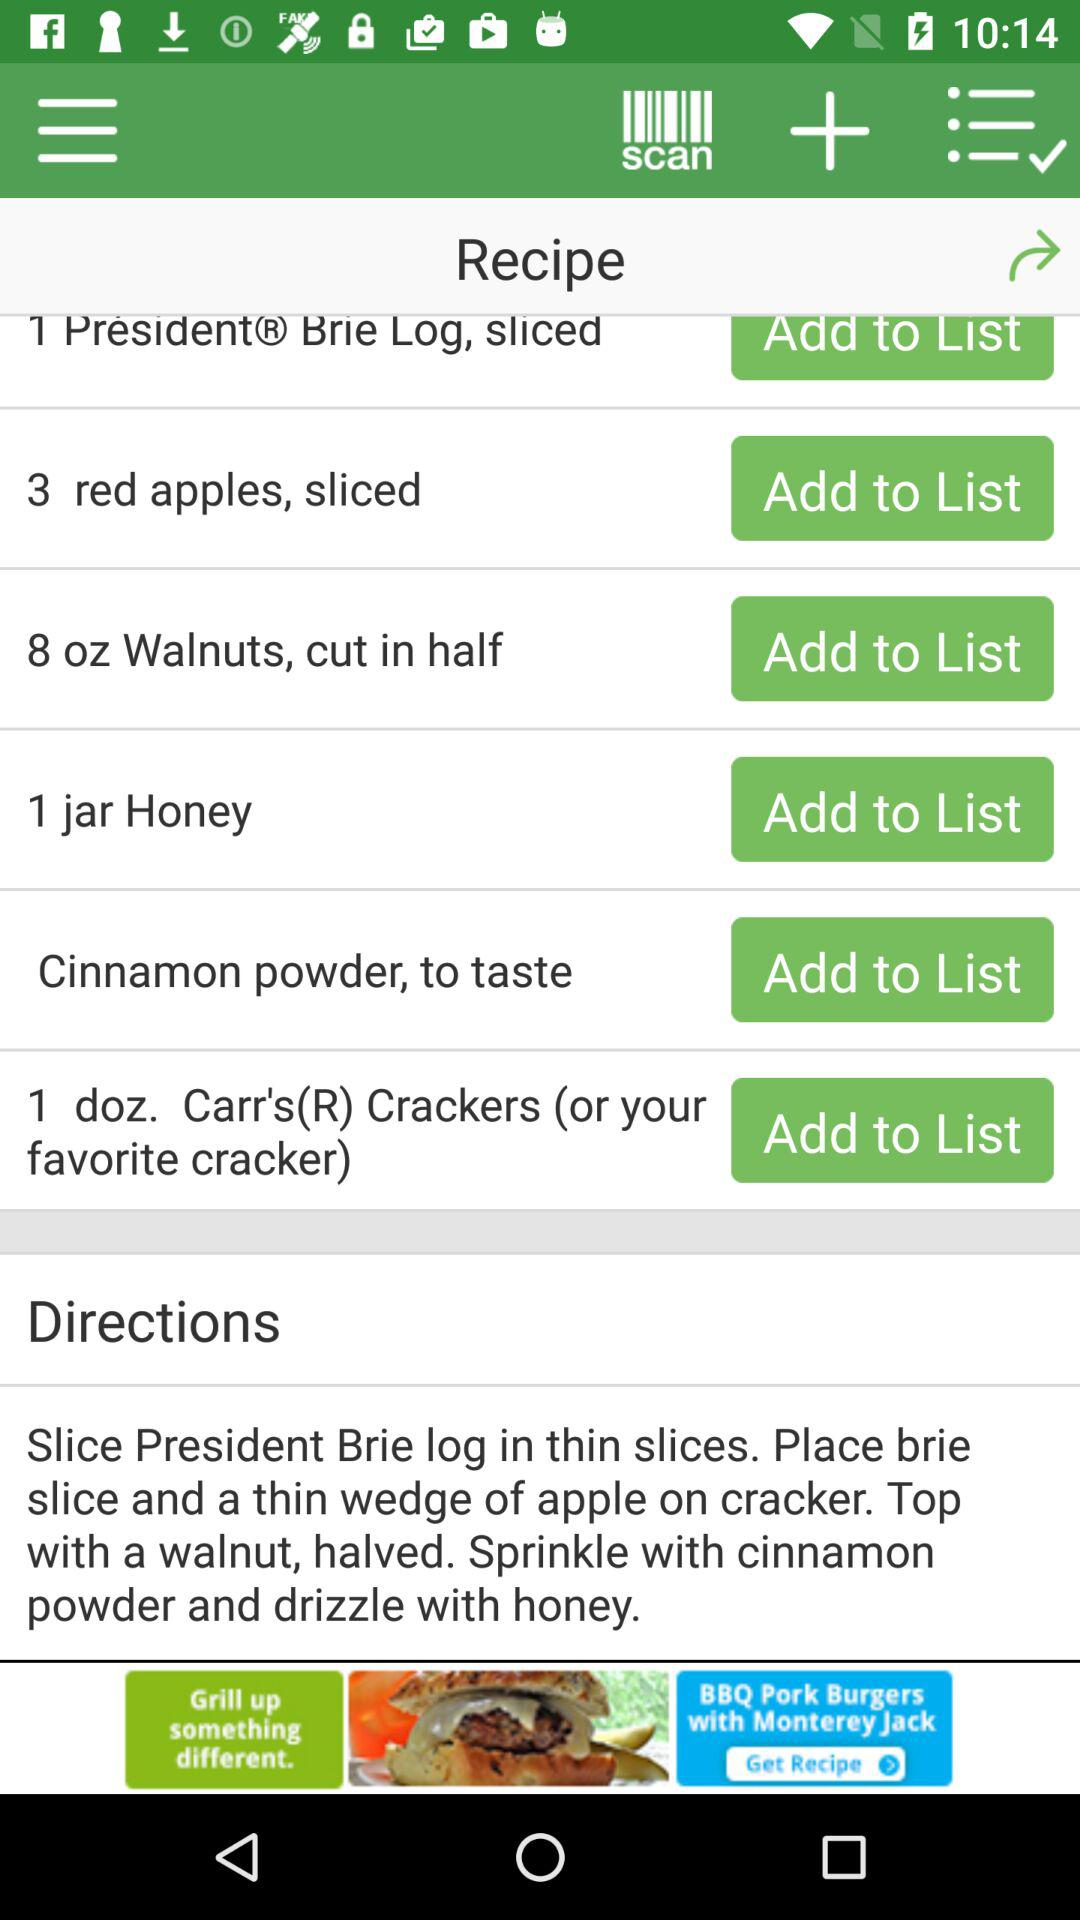How many red apples can be added to the list? The number of red apples that can be added to the list is 3. 